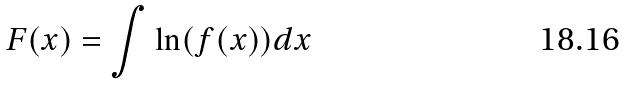Convert formula to latex. <formula><loc_0><loc_0><loc_500><loc_500>F ( x ) = \int \ln ( f ( x ) ) d x</formula> 